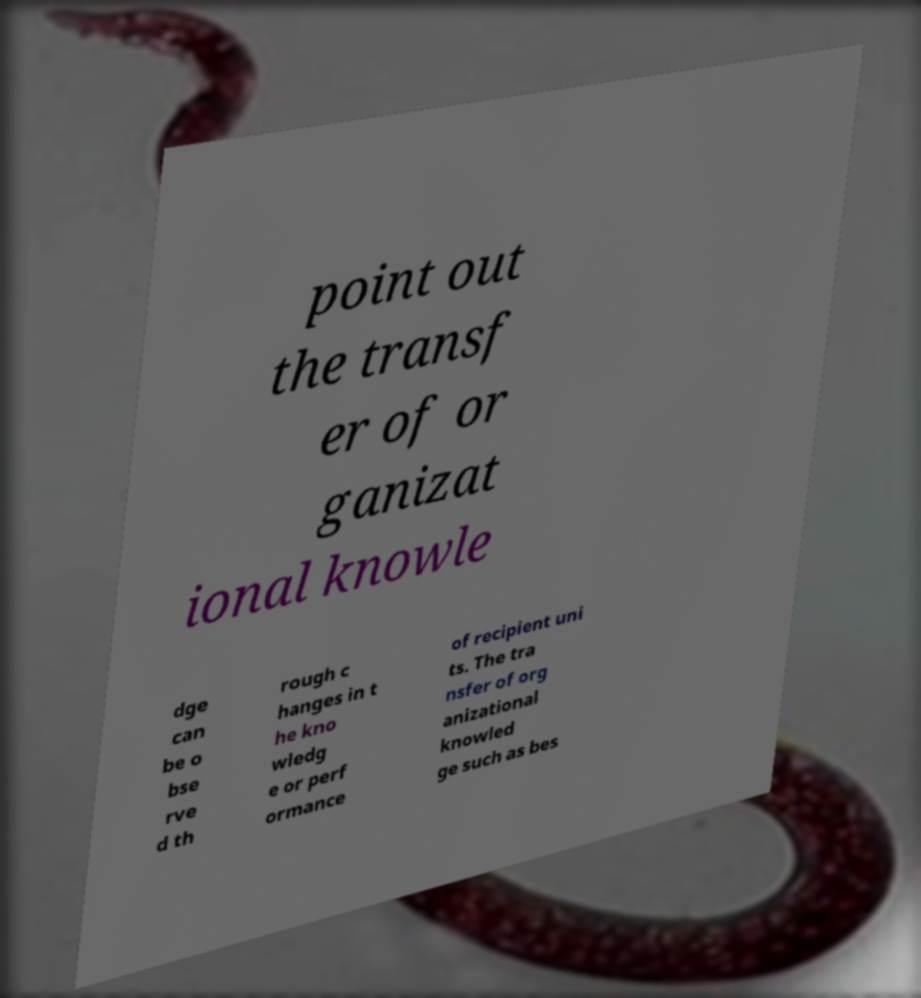What messages or text are displayed in this image? I need them in a readable, typed format. point out the transf er of or ganizat ional knowle dge can be o bse rve d th rough c hanges in t he kno wledg e or perf ormance of recipient uni ts. The tra nsfer of org anizational knowled ge such as bes 